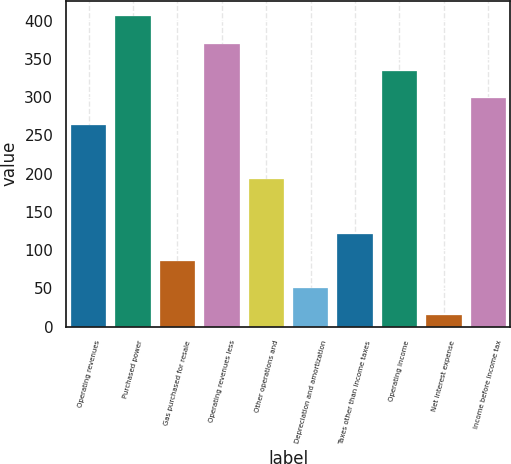Convert chart to OTSL. <chart><loc_0><loc_0><loc_500><loc_500><bar_chart><fcel>Operating revenues<fcel>Purchased power<fcel>Gas purchased for resale<fcel>Operating revenues less<fcel>Other operations and<fcel>Depreciation and amortization<fcel>Taxes other than income taxes<fcel>Operating income<fcel>Net interest expense<fcel>Income before income tax<nl><fcel>263.5<fcel>405.5<fcel>86<fcel>370<fcel>192.5<fcel>50.5<fcel>121.5<fcel>334.5<fcel>15<fcel>299<nl></chart> 